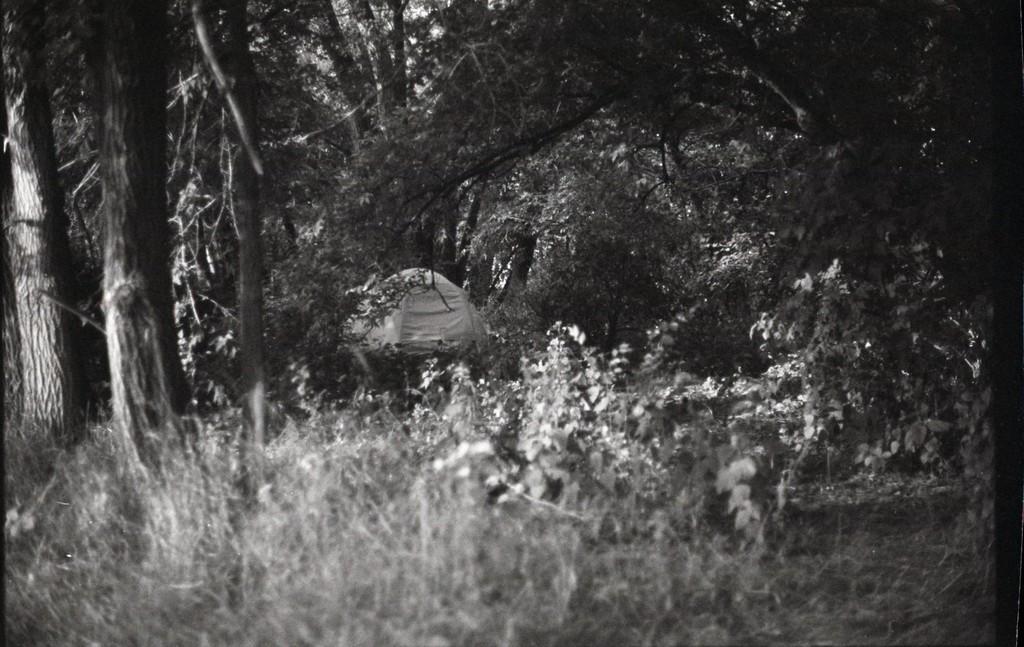Please provide a concise description of this image. In the picture there is a tent, there are many trees present. 